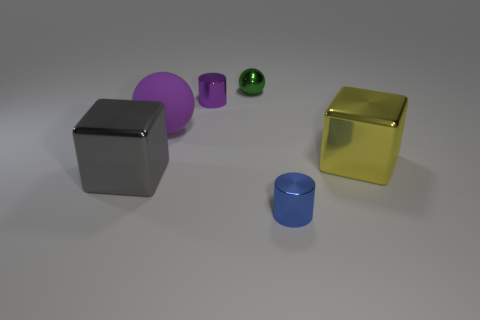Add 1 blue metal things. How many objects exist? 7 Subtract all spheres. How many objects are left? 4 Subtract all metallic blocks. Subtract all yellow objects. How many objects are left? 3 Add 6 big balls. How many big balls are left? 7 Add 5 large cyan shiny blocks. How many large cyan shiny blocks exist? 5 Subtract 0 red cylinders. How many objects are left? 6 